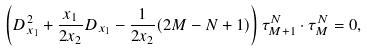Convert formula to latex. <formula><loc_0><loc_0><loc_500><loc_500>\left ( D _ { x _ { 1 } } ^ { 2 } + \frac { x _ { 1 } } { 2 x _ { 2 } } D _ { x _ { 1 } } - \frac { 1 } { 2 x _ { 2 } } ( 2 M - N + 1 ) \right ) \tau _ { M + 1 } ^ { N } \cdot \tau _ { M } ^ { N } = 0 ,</formula> 